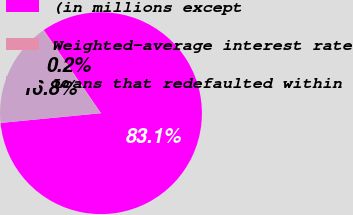<chart> <loc_0><loc_0><loc_500><loc_500><pie_chart><fcel>(in millions except<fcel>Weighted-average interest rate<fcel>Loans that redefaulted within<nl><fcel>83.06%<fcel>0.18%<fcel>16.76%<nl></chart> 